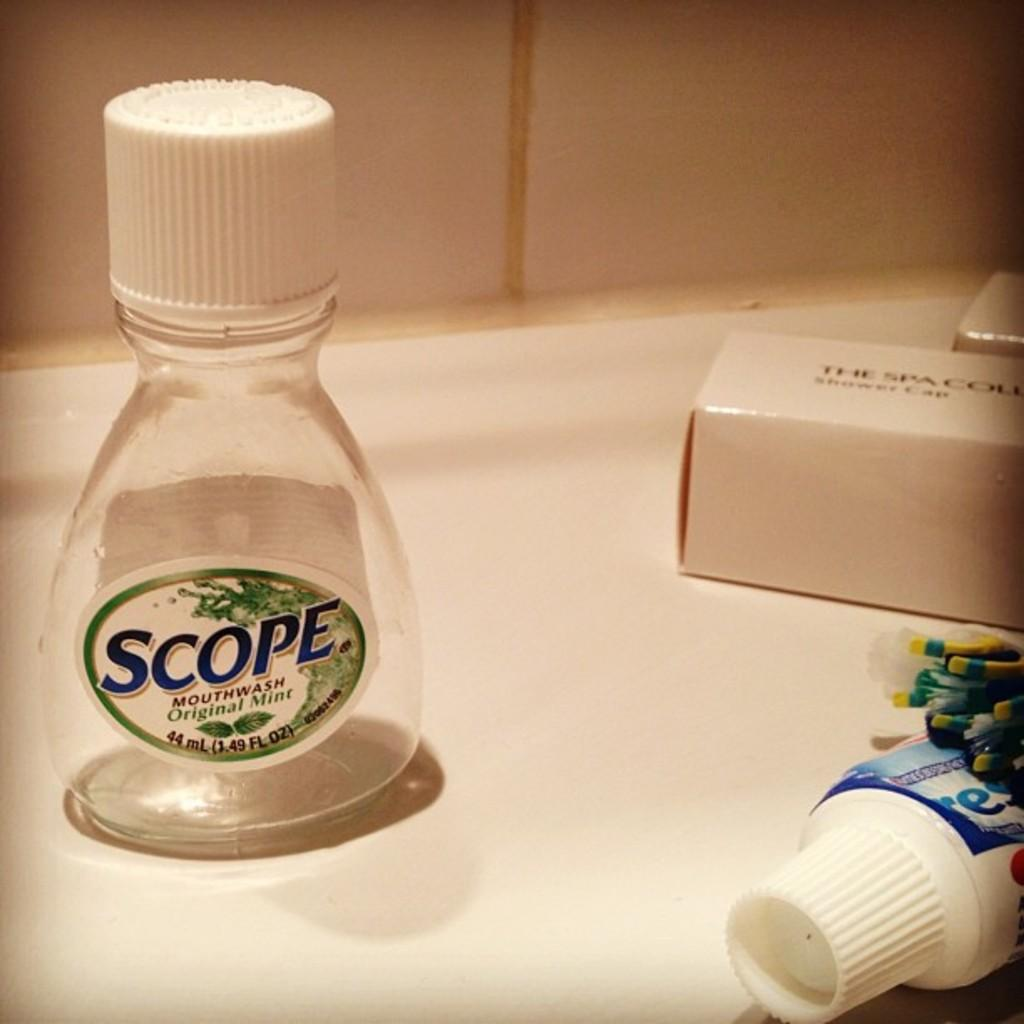<image>
Summarize the visual content of the image. Scope mouth wash and crest toothpaste along with a shower cap 